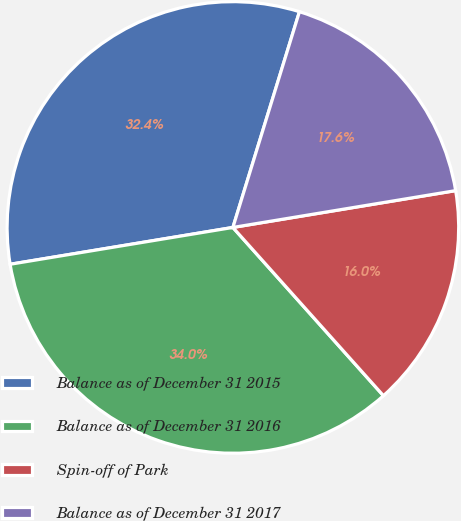Convert chart to OTSL. <chart><loc_0><loc_0><loc_500><loc_500><pie_chart><fcel>Balance as of December 31 2015<fcel>Balance as of December 31 2016<fcel>Spin-off of Park<fcel>Balance as of December 31 2017<nl><fcel>32.37%<fcel>34.01%<fcel>15.99%<fcel>17.63%<nl></chart> 